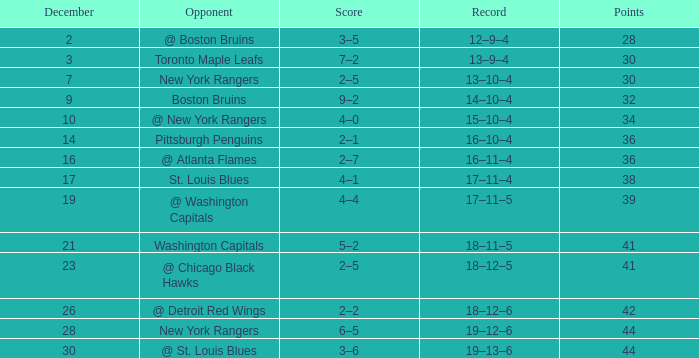Which Game has a Record of 14–10–4, and Points smaller than 32? None. 